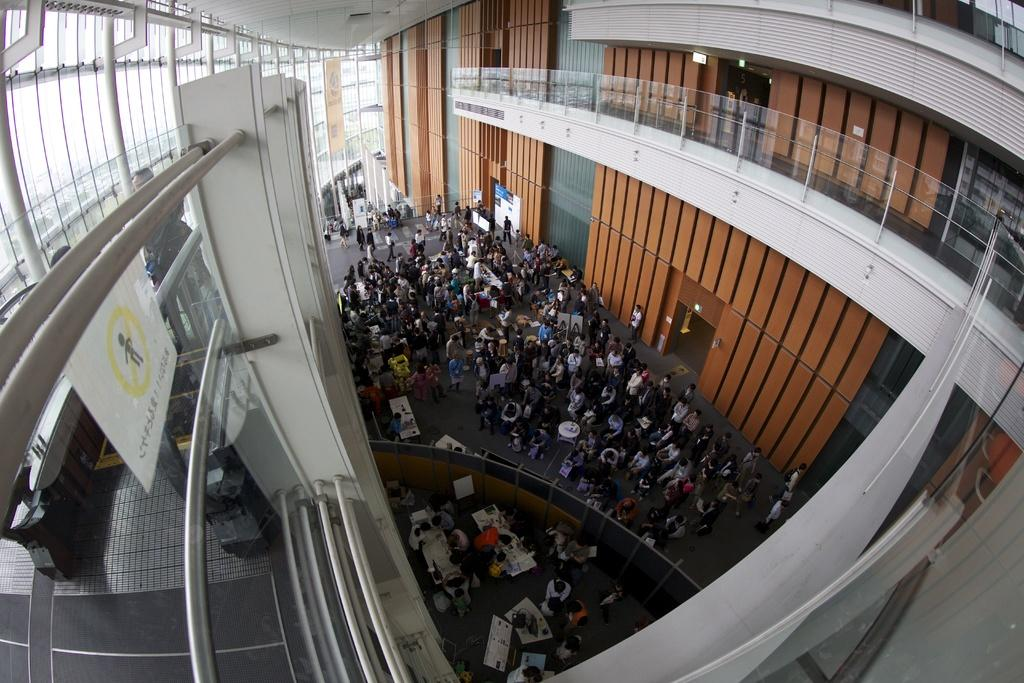What type of location is depicted in the image? The image shows an inside view of a house. Are there any people present in the house? Yes, there are people standing in the house. What feature can be seen in the house that allows natural light to enter? There are glass windows in the house. What architectural element is present in the house? There is a railing in the house. What can be found on the board inside the house? There is a board with some text in the house. How does the hall look like during the rainstorm in the image? There is no mention of a hall or rainstorm in the image; it shows an inside view of a house with people, glass windows, a railing, and a board with text. 